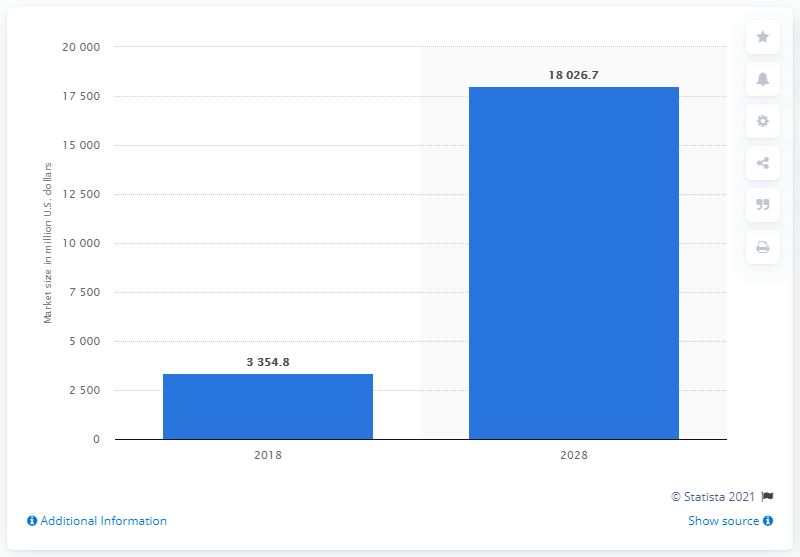Outline some significant characteristics in this image. By the year 2028, the market is expected to surpass 18 billion U.S. dollars in value. The market is forecasted to reach 18,026.7 by 2028. In 2018, the global market for next-generation sequencing-based monitoring and diagnostic tests was valued at approximately 3,354.8 million dollars. 